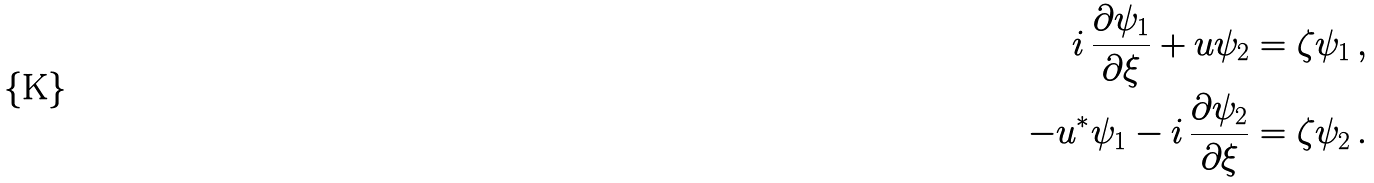Convert formula to latex. <formula><loc_0><loc_0><loc_500><loc_500>i \, \frac { \partial \psi _ { 1 } } { \partial \xi } + u \psi _ { 2 } = \zeta \psi _ { 1 } \, , \\ - u ^ { * } \psi _ { 1 } - i \, \frac { \partial \psi _ { 2 } } { \partial \xi } = \zeta \psi _ { 2 } \, .</formula> 